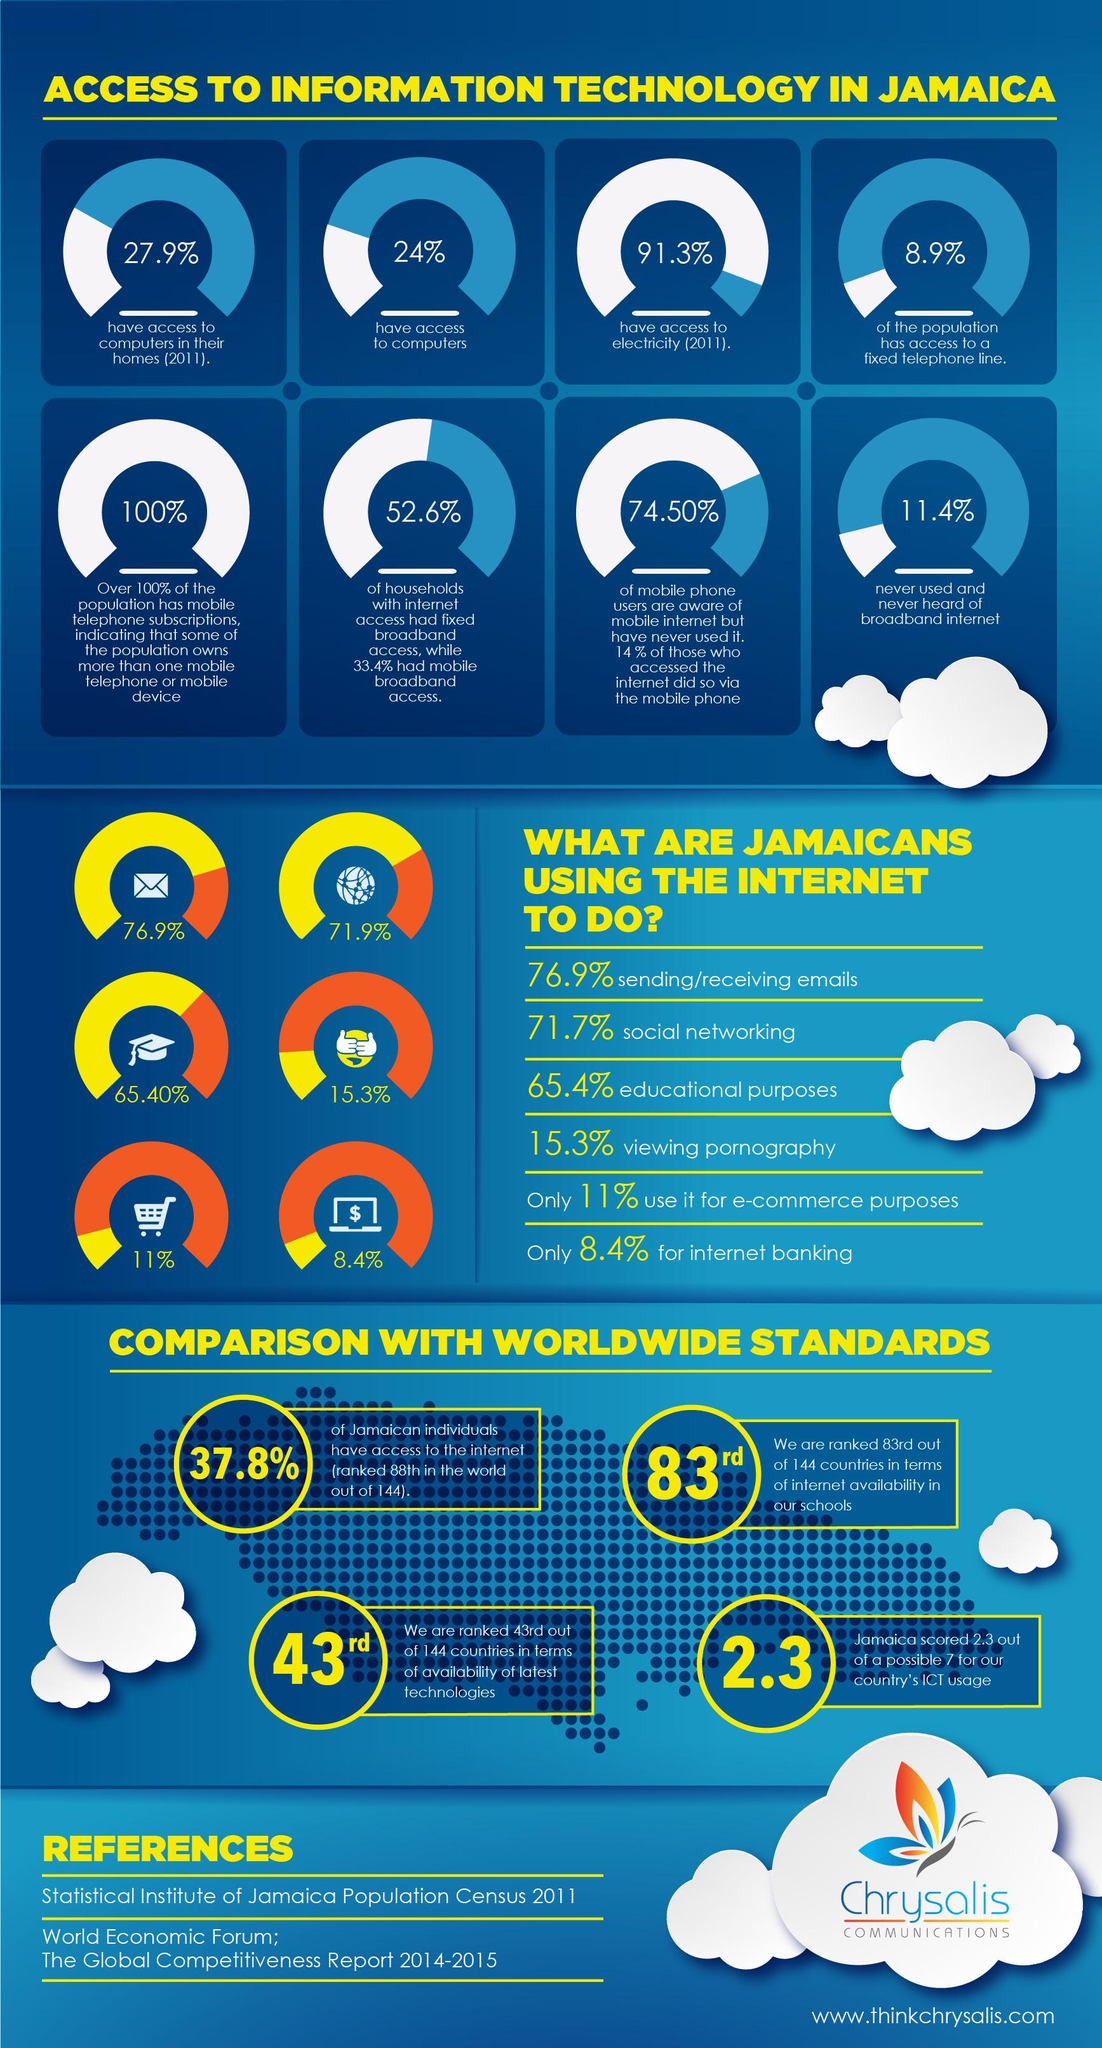Draw attention to some important aspects in this diagram. According to a recent survey, 15.3% of Jamaicans use the internet to view pornography. It can be declared that sending and receiving emails is the most frequently performed task by Jamaicans when using the internet. The task of internet banking is the least performed by Jamaicans using the internet. In 2011, it was reported that 91.3% of Jamaicans had access to electricity. Jamaica's score for the country's ICT usage is 2.3. 